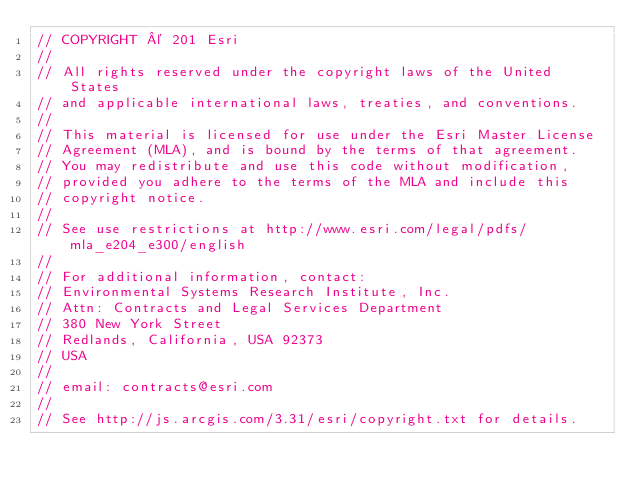Convert code to text. <code><loc_0><loc_0><loc_500><loc_500><_JavaScript_>// COPYRIGHT © 201 Esri
//
// All rights reserved under the copyright laws of the United States
// and applicable international laws, treaties, and conventions.
//
// This material is licensed for use under the Esri Master License
// Agreement (MLA), and is bound by the terms of that agreement.
// You may redistribute and use this code without modification,
// provided you adhere to the terms of the MLA and include this
// copyright notice.
//
// See use restrictions at http://www.esri.com/legal/pdfs/mla_e204_e300/english
//
// For additional information, contact:
// Environmental Systems Research Institute, Inc.
// Attn: Contracts and Legal Services Department
// 380 New York Street
// Redlands, California, USA 92373
// USA
//
// email: contracts@esri.com
//
// See http://js.arcgis.com/3.31/esri/copyright.txt for details.
</code> 